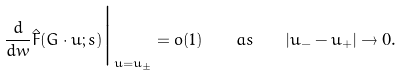Convert formula to latex. <formula><loc_0><loc_0><loc_500><loc_500>\frac { d } { d w } \hat { F } ( G \cdot u ; s ) \Big | _ { u = u _ { \pm } } = o ( 1 ) \quad a s \quad | u _ { - } - u _ { + } | \to 0 .</formula> 